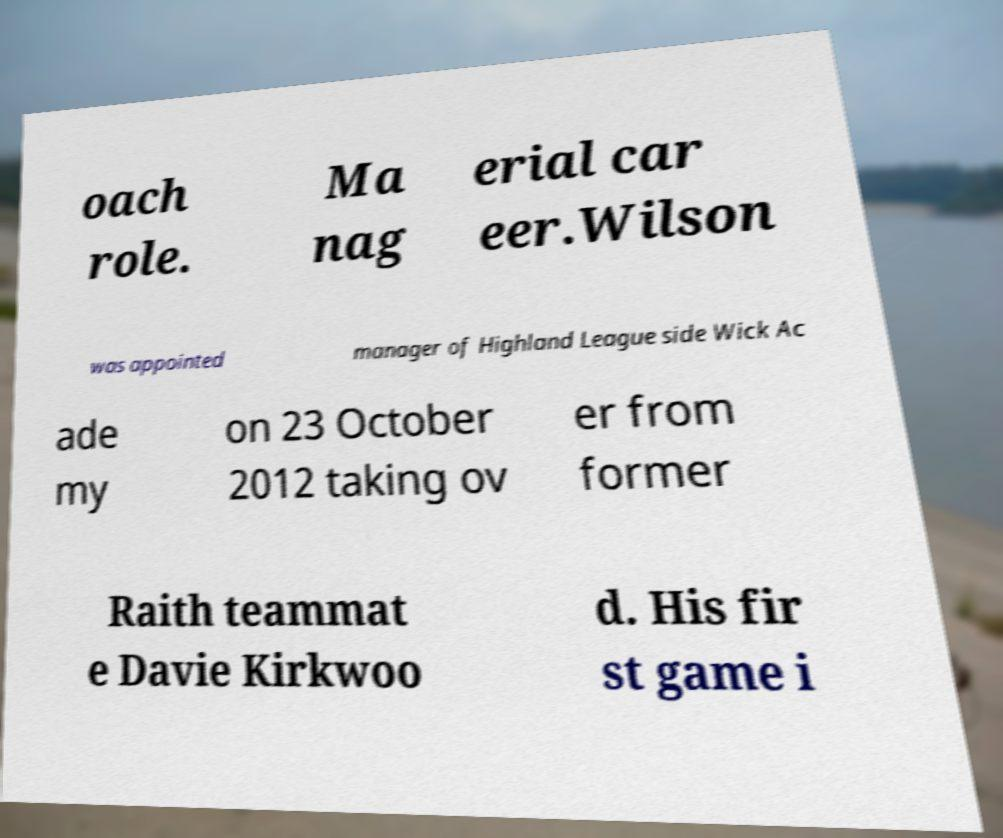Could you extract and type out the text from this image? oach role. Ma nag erial car eer.Wilson was appointed manager of Highland League side Wick Ac ade my on 23 October 2012 taking ov er from former Raith teammat e Davie Kirkwoo d. His fir st game i 